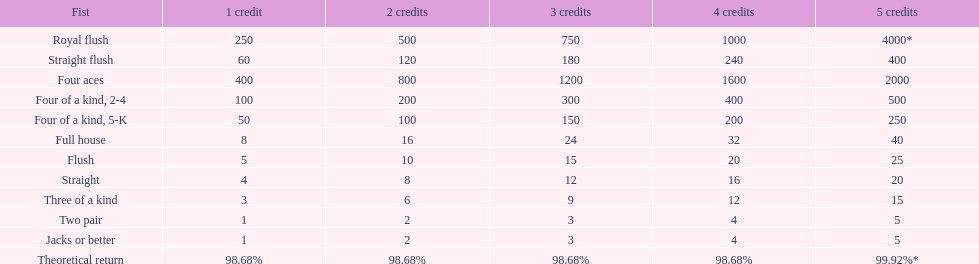What is the reward for obtaining a full house and winning using four credits? 32. 